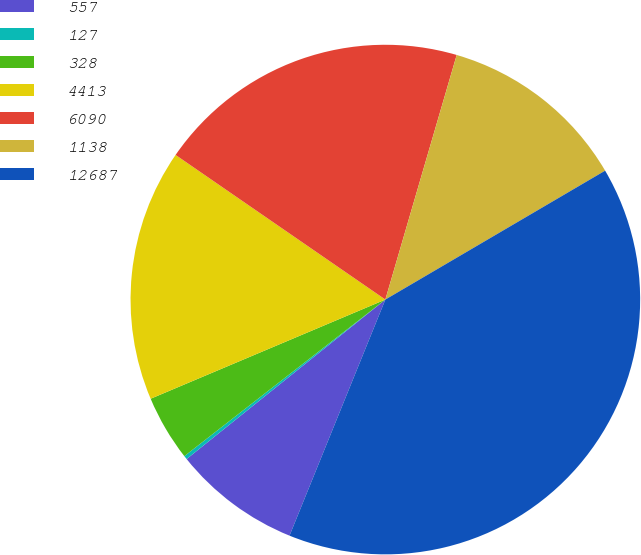Convert chart. <chart><loc_0><loc_0><loc_500><loc_500><pie_chart><fcel>557<fcel>127<fcel>328<fcel>4413<fcel>6090<fcel>1138<fcel>12687<nl><fcel>8.1%<fcel>0.23%<fcel>4.17%<fcel>15.97%<fcel>19.91%<fcel>12.04%<fcel>39.58%<nl></chart> 